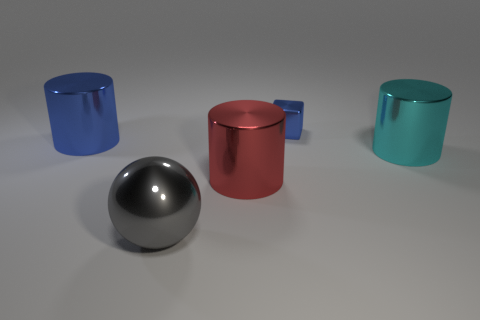Add 3 large cyan metal things. How many objects exist? 8 Subtract all cyan cylinders. How many cylinders are left? 2 Subtract all spheres. How many objects are left? 4 Subtract 1 cylinders. How many cylinders are left? 2 Subtract all tiny brown things. Subtract all blue cylinders. How many objects are left? 4 Add 4 shiny blocks. How many shiny blocks are left? 5 Add 5 red matte cylinders. How many red matte cylinders exist? 5 Subtract 0 cyan balls. How many objects are left? 5 Subtract all yellow cylinders. Subtract all cyan cubes. How many cylinders are left? 3 